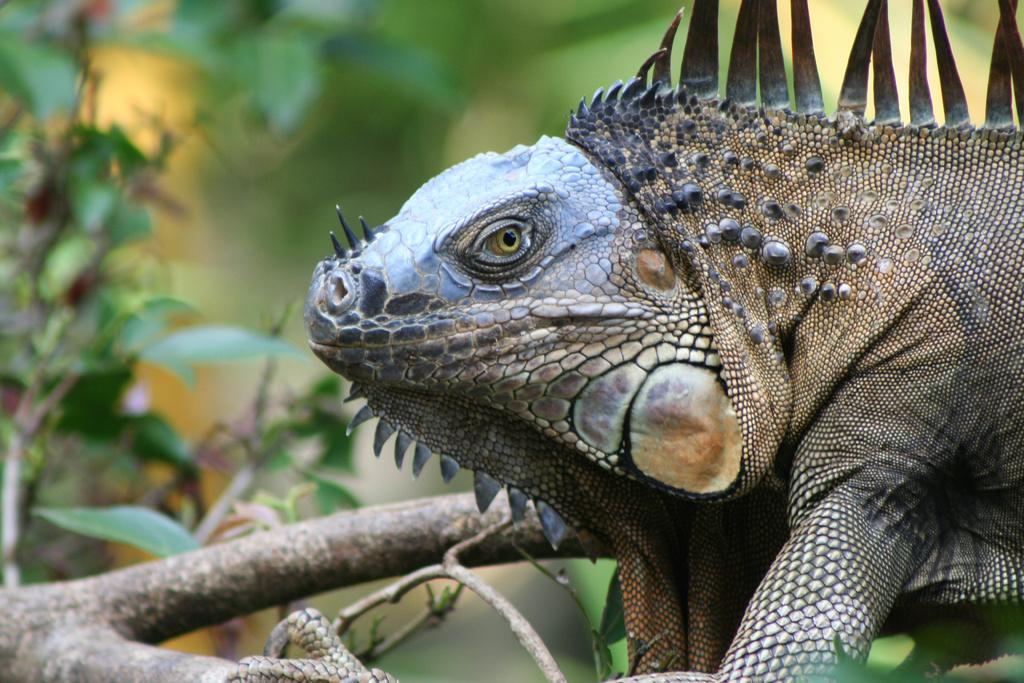What type of animal is in the image? There is a reptile in the image. Where is the reptile located? The reptile is on a tree branch. What can be seen on the left side of the image? There are trees with leaves on the left side of the image. How would you describe the background of the image? The background appears blurry. What type of furniture can be seen in the image? There is no furniture present in the image; it features a reptile on a tree branch. How many crows are perched on the tree branch with the reptile? There are no crows present in the image; only the reptile is visible on the tree branch. 